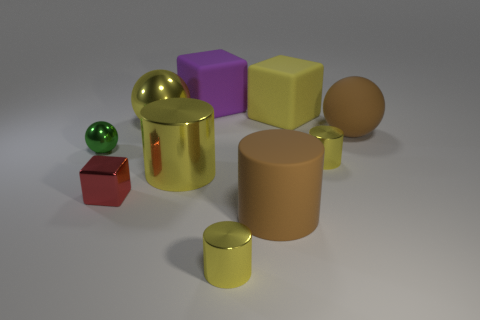Subtract all cyan balls. How many yellow cylinders are left? 3 Subtract all cylinders. How many objects are left? 6 Subtract all metallic blocks. Subtract all brown rubber cylinders. How many objects are left? 8 Add 8 yellow metallic spheres. How many yellow metallic spheres are left? 9 Add 8 brown things. How many brown things exist? 10 Subtract 0 cyan cylinders. How many objects are left? 10 